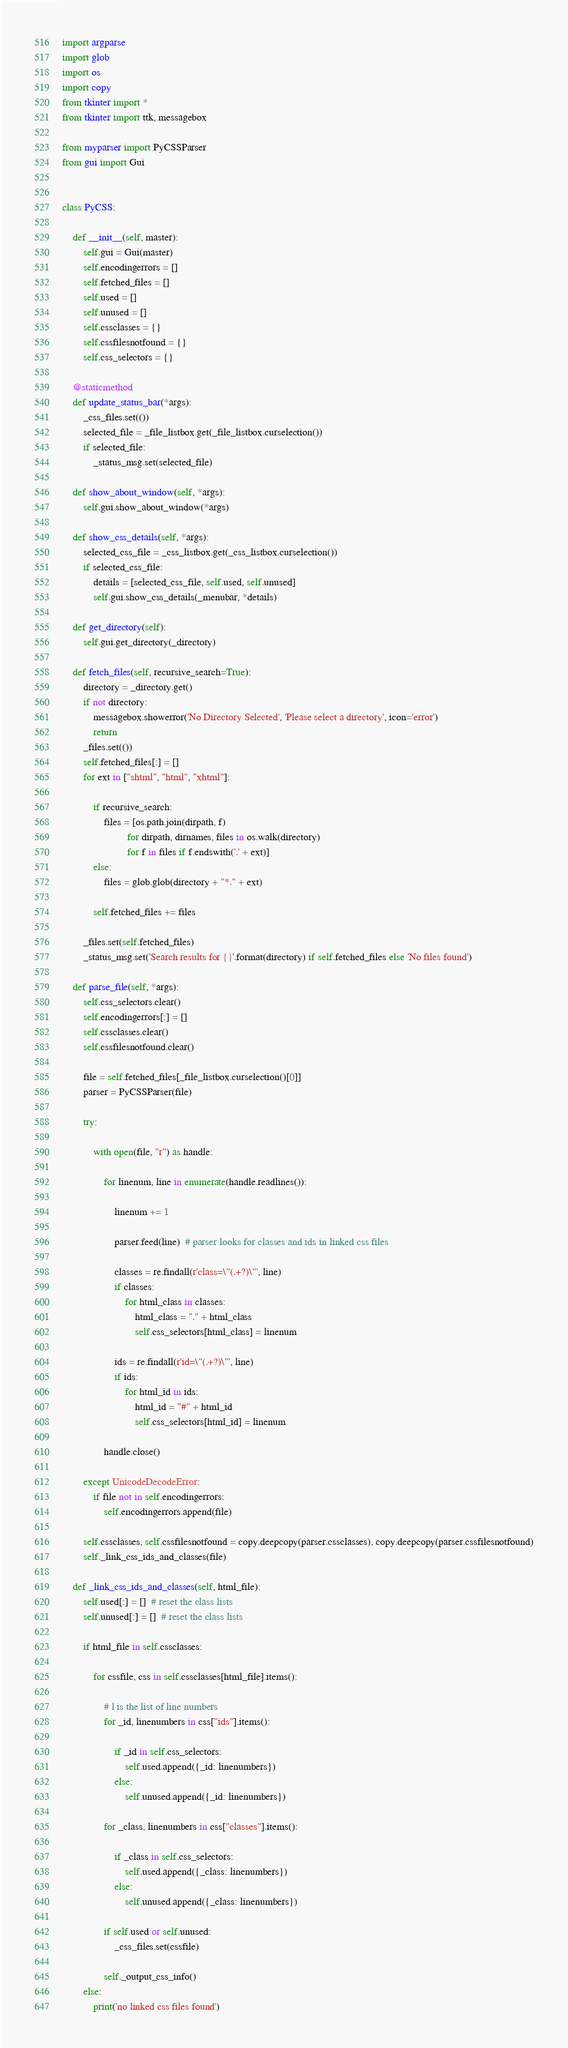<code> <loc_0><loc_0><loc_500><loc_500><_Python_>import argparse
import glob
import os
import copy
from tkinter import *
from tkinter import ttk, messagebox

from myparser import PyCSSParser
from gui import Gui


class PyCSS:

    def __init__(self, master):
        self.gui = Gui(master)
        self.encodingerrors = []
        self.fetched_files = []
        self.used = []
        self.unused = []
        self.cssclasses = {}
        self.cssfilesnotfound = {}
        self.css_selectors = {}

    @staticmethod
    def update_status_bar(*args):
        _css_files.set(())
        selected_file = _file_listbox.get(_file_listbox.curselection())
        if selected_file:
            _status_msg.set(selected_file)

    def show_about_window(self, *args):
        self.gui.show_about_window(*args)

    def show_css_details(self, *args):
        selected_css_file = _css_listbox.get(_css_listbox.curselection())
        if selected_css_file:
            details = [selected_css_file, self.used, self.unused]
            self.gui.show_css_details(_menubar, *details)

    def get_directory(self):
        self.gui.get_directory(_directory)

    def fetch_files(self, recursive_search=True):
        directory = _directory.get()
        if not directory:
            messagebox.showerror('No Directory Selected', 'Please select a directory', icon='error')
            return
        _files.set(())
        self.fetched_files[:] = []
        for ext in ["shtml", "html", "xhtml"]:

            if recursive_search:
                files = [os.path.join(dirpath, f)
                         for dirpath, dirnames, files in os.walk(directory)
                         for f in files if f.endswith('.' + ext)]
            else:
                files = glob.glob(directory + "*." + ext)

            self.fetched_files += files

        _files.set(self.fetched_files)
        _status_msg.set('Search results for {}'.format(directory) if self.fetched_files else 'No files found')

    def parse_file(self, *args):
        self.css_selectors.clear()
        self.encodingerrors[:] = []
        self.cssclasses.clear()
        self.cssfilesnotfound.clear()

        file = self.fetched_files[_file_listbox.curselection()[0]]
        parser = PyCSSParser(file)

        try:

            with open(file, "r") as handle:

                for linenum, line in enumerate(handle.readlines()):

                    linenum += 1

                    parser.feed(line)  # parser looks for classes and ids in linked css files

                    classes = re.findall(r'class=\"(.+?)\"', line)
                    if classes:
                        for html_class in classes:
                            html_class = "." + html_class
                            self.css_selectors[html_class] = linenum

                    ids = re.findall(r'id=\"(.+?)\"', line)
                    if ids:
                        for html_id in ids:
                            html_id = "#" + html_id
                            self.css_selectors[html_id] = linenum

                handle.close()

        except UnicodeDecodeError:
            if file not in self.encodingerrors:
                self.encodingerrors.append(file)

        self.cssclasses, self.cssfilesnotfound = copy.deepcopy(parser.cssclasses), copy.deepcopy(parser.cssfilesnotfound)
        self._link_css_ids_and_classes(file)

    def _link_css_ids_and_classes(self, html_file):
        self.used[:] = []  # reset the class lists
        self.unused[:] = []  # reset the class lists

        if html_file in self.cssclasses:

            for cssfile, css in self.cssclasses[html_file].items():

                # l is the list of line numbers
                for _id, linenumbers in css["ids"].items():

                    if _id in self.css_selectors:
                        self.used.append({_id: linenumbers})
                    else:
                        self.unused.append({_id: linenumbers})

                for _class, linenumbers in css["classes"].items():

                    if _class in self.css_selectors:
                        self.used.append({_class: linenumbers})
                    else:
                        self.unused.append({_class: linenumbers})

                if self.used or self.unused:
                    _css_files.set(cssfile)

                self._output_css_info()
        else:
            print('no linked css files found')
</code> 